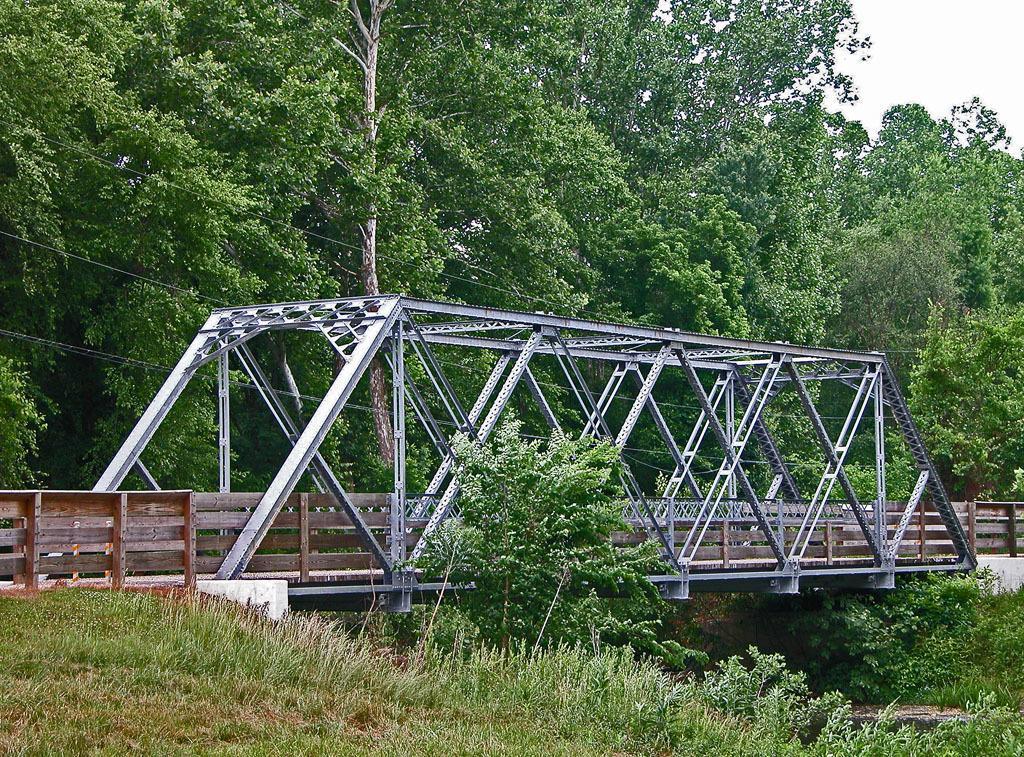In one or two sentences, can you explain what this image depicts? In the image we can see the bridge made up of metal and wood. Here we can see grass, trees, electric wires and the sky. 